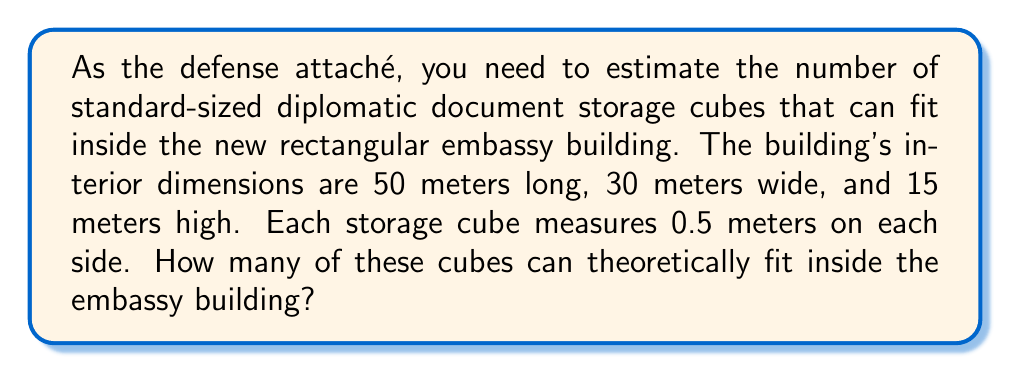Can you answer this question? To solve this problem, we need to follow these steps:

1. Calculate the volume of the embassy building:
   $$V_{building} = length \times width \times height$$
   $$V_{building} = 50 \text{ m} \times 30 \text{ m} \times 15 \text{ m} = 22,500 \text{ m}^3$$

2. Calculate the volume of each storage cube:
   $$V_{cube} = side^3$$
   $$V_{cube} = (0.5 \text{ m})^3 = 0.125 \text{ m}^3$$

3. Calculate the number of cubes that can fit by dividing the building volume by the cube volume:
   $$N_{cubes} = \frac{V_{building}}{V_{cube}}$$
   $$N_{cubes} = \frac{22,500 \text{ m}^3}{0.125 \text{ m}^3} = 180,000$$

Therefore, theoretically, 180,000 storage cubes can fit inside the embassy building.

Note: This calculation assumes perfect packing with no space between cubes and no consideration for practical limitations such as doorways, corridors, or other building features. In reality, the actual number of cubes that could be placed would be significantly less.
Answer: 180,000 cubes 